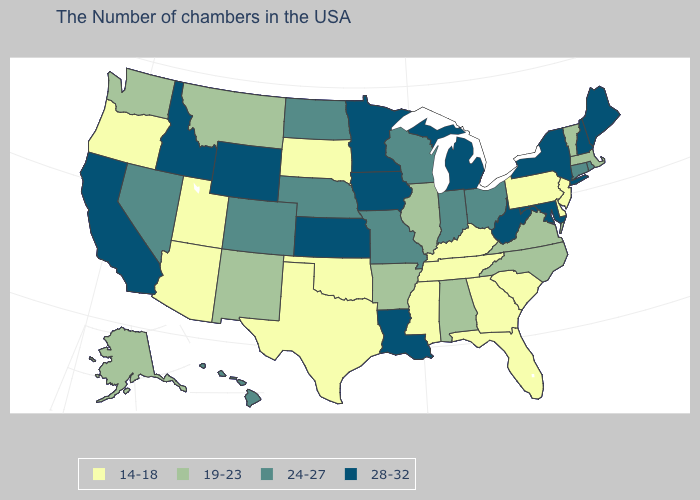What is the value of Oregon?
Be succinct. 14-18. Name the states that have a value in the range 14-18?
Short answer required. New Jersey, Delaware, Pennsylvania, South Carolina, Florida, Georgia, Kentucky, Tennessee, Mississippi, Oklahoma, Texas, South Dakota, Utah, Arizona, Oregon. What is the value of Vermont?
Keep it brief. 19-23. Which states have the lowest value in the USA?
Answer briefly. New Jersey, Delaware, Pennsylvania, South Carolina, Florida, Georgia, Kentucky, Tennessee, Mississippi, Oklahoma, Texas, South Dakota, Utah, Arizona, Oregon. What is the value of Florida?
Short answer required. 14-18. Which states hav the highest value in the South?
Write a very short answer. Maryland, West Virginia, Louisiana. Does South Dakota have the lowest value in the MidWest?
Answer briefly. Yes. Which states hav the highest value in the MidWest?
Write a very short answer. Michigan, Minnesota, Iowa, Kansas. Is the legend a continuous bar?
Short answer required. No. Which states have the lowest value in the USA?
Give a very brief answer. New Jersey, Delaware, Pennsylvania, South Carolina, Florida, Georgia, Kentucky, Tennessee, Mississippi, Oklahoma, Texas, South Dakota, Utah, Arizona, Oregon. Name the states that have a value in the range 19-23?
Quick response, please. Massachusetts, Vermont, Virginia, North Carolina, Alabama, Illinois, Arkansas, New Mexico, Montana, Washington, Alaska. How many symbols are there in the legend?
Quick response, please. 4. Name the states that have a value in the range 28-32?
Give a very brief answer. Maine, New Hampshire, New York, Maryland, West Virginia, Michigan, Louisiana, Minnesota, Iowa, Kansas, Wyoming, Idaho, California. What is the value of New Hampshire?
Be succinct. 28-32. Does Maryland have the same value as Maine?
Quick response, please. Yes. 